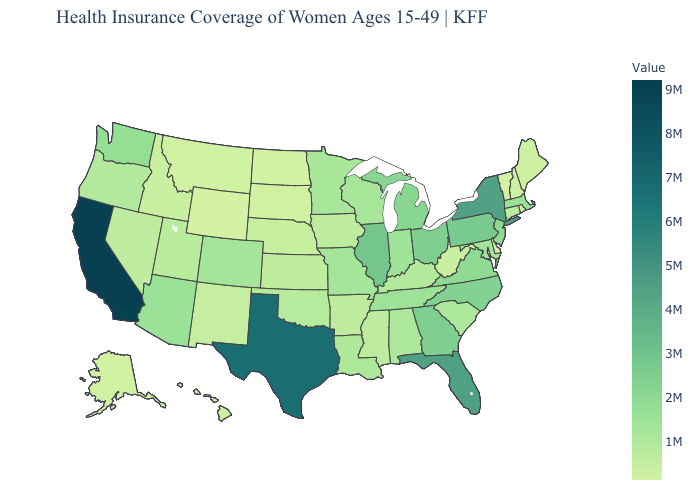Among the states that border Florida , which have the lowest value?
Answer briefly. Alabama. Does Kansas have the highest value in the MidWest?
Short answer required. No. Does Oklahoma have a lower value than Ohio?
Concise answer only. Yes. Does Texas have a lower value than California?
Keep it brief. Yes. 